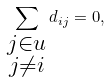<formula> <loc_0><loc_0><loc_500><loc_500>\sum _ { \substack { j \in u \\ j \ne i } } d _ { i j } = 0 ,</formula> 